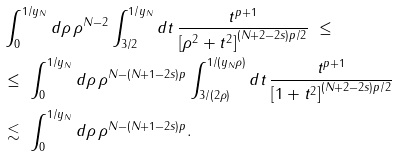<formula> <loc_0><loc_0><loc_500><loc_500>& \int _ { 0 } ^ { 1 / y _ { N } } d \rho \, \rho ^ { N - 2 } \int _ { 3 / 2 } ^ { 1 / y _ { N } } d t \, \frac { t ^ { p + 1 } } { \left [ \rho ^ { 2 } + t ^ { 2 } \right ] ^ { ( N + 2 - 2 s ) p / 2 } } \ \leq \\ & \leq \ \int _ { 0 } ^ { 1 / y _ { N } } d \rho \, \rho ^ { N - ( N + 1 - 2 s ) p } \int _ { 3 / ( 2 \rho ) } ^ { 1 / ( y _ { N } \rho ) } d t \, \frac { t ^ { p + 1 } } { \left [ 1 + t ^ { 2 } \right ] ^ { ( N + 2 - 2 s ) p / 2 } } \\ & \lesssim \ \int _ { 0 } ^ { 1 / y _ { N } } d \rho \, \rho ^ { N - ( N + 1 - 2 s ) p } .</formula> 